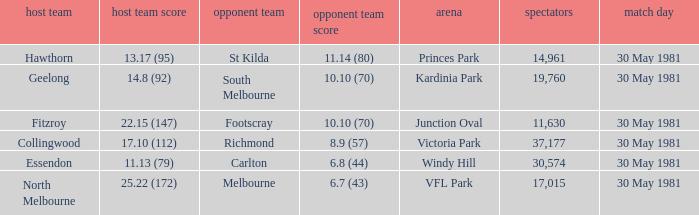What did carlton score while away? 6.8 (44). 